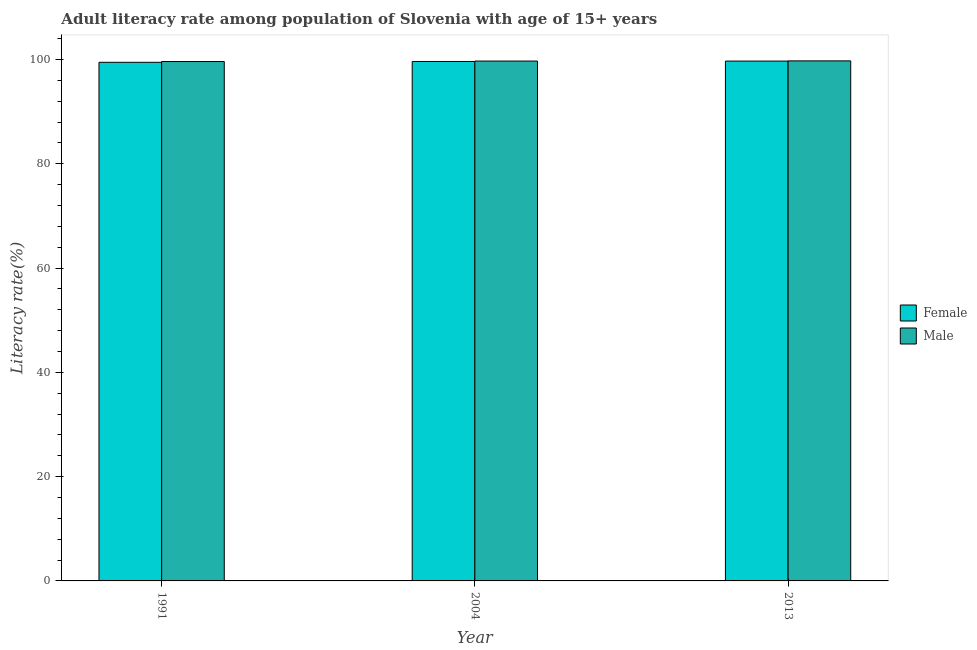How many groups of bars are there?
Give a very brief answer. 3. Are the number of bars per tick equal to the number of legend labels?
Provide a short and direct response. Yes. How many bars are there on the 3rd tick from the left?
Offer a terse response. 2. How many bars are there on the 2nd tick from the right?
Make the answer very short. 2. What is the label of the 2nd group of bars from the left?
Ensure brevity in your answer.  2004. In how many cases, is the number of bars for a given year not equal to the number of legend labels?
Offer a terse response. 0. What is the female adult literacy rate in 2004?
Your response must be concise. 99.62. Across all years, what is the maximum female adult literacy rate?
Give a very brief answer. 99.69. Across all years, what is the minimum male adult literacy rate?
Your response must be concise. 99.6. In which year was the male adult literacy rate minimum?
Your answer should be very brief. 1991. What is the total female adult literacy rate in the graph?
Offer a terse response. 298.75. What is the difference between the female adult literacy rate in 1991 and that in 2004?
Provide a short and direct response. -0.16. What is the difference between the female adult literacy rate in 1991 and the male adult literacy rate in 2004?
Your answer should be compact. -0.16. What is the average male adult literacy rate per year?
Provide a short and direct response. 99.67. In the year 2013, what is the difference between the male adult literacy rate and female adult literacy rate?
Offer a very short reply. 0. What is the ratio of the female adult literacy rate in 1991 to that in 2004?
Provide a succinct answer. 1. Is the female adult literacy rate in 1991 less than that in 2004?
Provide a short and direct response. Yes. What is the difference between the highest and the second highest male adult literacy rate?
Ensure brevity in your answer.  0.04. What is the difference between the highest and the lowest female adult literacy rate?
Your answer should be compact. 0.23. In how many years, is the female adult literacy rate greater than the average female adult literacy rate taken over all years?
Your answer should be compact. 2. What does the 1st bar from the left in 1991 represents?
Make the answer very short. Female. How many bars are there?
Ensure brevity in your answer.  6. How many years are there in the graph?
Make the answer very short. 3. Does the graph contain grids?
Keep it short and to the point. No. Where does the legend appear in the graph?
Keep it short and to the point. Center right. How are the legend labels stacked?
Offer a very short reply. Vertical. What is the title of the graph?
Keep it short and to the point. Adult literacy rate among population of Slovenia with age of 15+ years. Does "Time to export" appear as one of the legend labels in the graph?
Offer a very short reply. No. What is the label or title of the Y-axis?
Make the answer very short. Literacy rate(%). What is the Literacy rate(%) of Female in 1991?
Your answer should be very brief. 99.45. What is the Literacy rate(%) in Male in 1991?
Give a very brief answer. 99.6. What is the Literacy rate(%) in Female in 2004?
Give a very brief answer. 99.62. What is the Literacy rate(%) in Male in 2004?
Your answer should be compact. 99.69. What is the Literacy rate(%) in Female in 2013?
Make the answer very short. 99.69. What is the Literacy rate(%) in Male in 2013?
Keep it short and to the point. 99.73. Across all years, what is the maximum Literacy rate(%) in Female?
Give a very brief answer. 99.69. Across all years, what is the maximum Literacy rate(%) of Male?
Offer a terse response. 99.73. Across all years, what is the minimum Literacy rate(%) of Female?
Your response must be concise. 99.45. Across all years, what is the minimum Literacy rate(%) of Male?
Offer a very short reply. 99.6. What is the total Literacy rate(%) of Female in the graph?
Provide a succinct answer. 298.75. What is the total Literacy rate(%) in Male in the graph?
Offer a very short reply. 299.02. What is the difference between the Literacy rate(%) of Female in 1991 and that in 2004?
Offer a terse response. -0.16. What is the difference between the Literacy rate(%) in Male in 1991 and that in 2004?
Provide a succinct answer. -0.09. What is the difference between the Literacy rate(%) of Female in 1991 and that in 2013?
Your answer should be compact. -0.23. What is the difference between the Literacy rate(%) of Male in 1991 and that in 2013?
Your answer should be very brief. -0.12. What is the difference between the Literacy rate(%) of Female in 2004 and that in 2013?
Offer a very short reply. -0.07. What is the difference between the Literacy rate(%) of Male in 2004 and that in 2013?
Give a very brief answer. -0.04. What is the difference between the Literacy rate(%) of Female in 1991 and the Literacy rate(%) of Male in 2004?
Give a very brief answer. -0.24. What is the difference between the Literacy rate(%) in Female in 1991 and the Literacy rate(%) in Male in 2013?
Offer a terse response. -0.27. What is the difference between the Literacy rate(%) in Female in 2004 and the Literacy rate(%) in Male in 2013?
Make the answer very short. -0.11. What is the average Literacy rate(%) of Female per year?
Make the answer very short. 99.58. What is the average Literacy rate(%) of Male per year?
Offer a terse response. 99.67. In the year 1991, what is the difference between the Literacy rate(%) of Female and Literacy rate(%) of Male?
Your answer should be compact. -0.15. In the year 2004, what is the difference between the Literacy rate(%) of Female and Literacy rate(%) of Male?
Ensure brevity in your answer.  -0.08. In the year 2013, what is the difference between the Literacy rate(%) of Female and Literacy rate(%) of Male?
Provide a succinct answer. -0.04. What is the ratio of the Literacy rate(%) of Male in 1991 to that in 2013?
Offer a terse response. 1. What is the ratio of the Literacy rate(%) of Male in 2004 to that in 2013?
Your answer should be very brief. 1. What is the difference between the highest and the second highest Literacy rate(%) of Female?
Make the answer very short. 0.07. What is the difference between the highest and the second highest Literacy rate(%) in Male?
Offer a very short reply. 0.04. What is the difference between the highest and the lowest Literacy rate(%) in Female?
Ensure brevity in your answer.  0.23. What is the difference between the highest and the lowest Literacy rate(%) of Male?
Your answer should be compact. 0.12. 